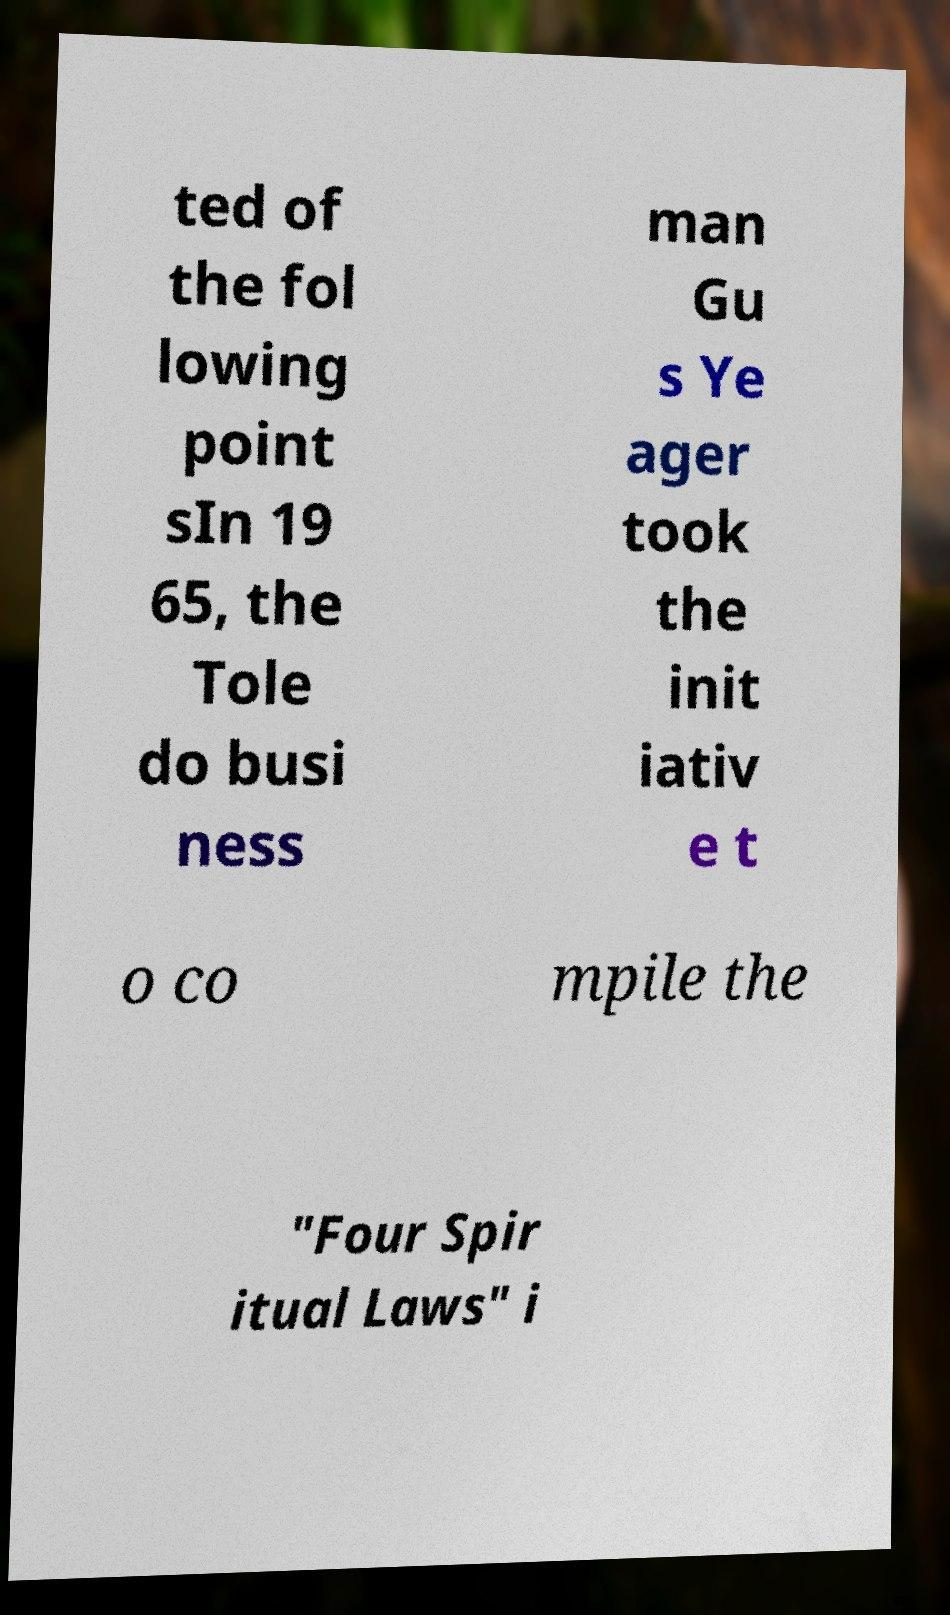What messages or text are displayed in this image? I need them in a readable, typed format. ted of the fol lowing point sIn 19 65, the Tole do busi ness man Gu s Ye ager took the init iativ e t o co mpile the "Four Spir itual Laws" i 